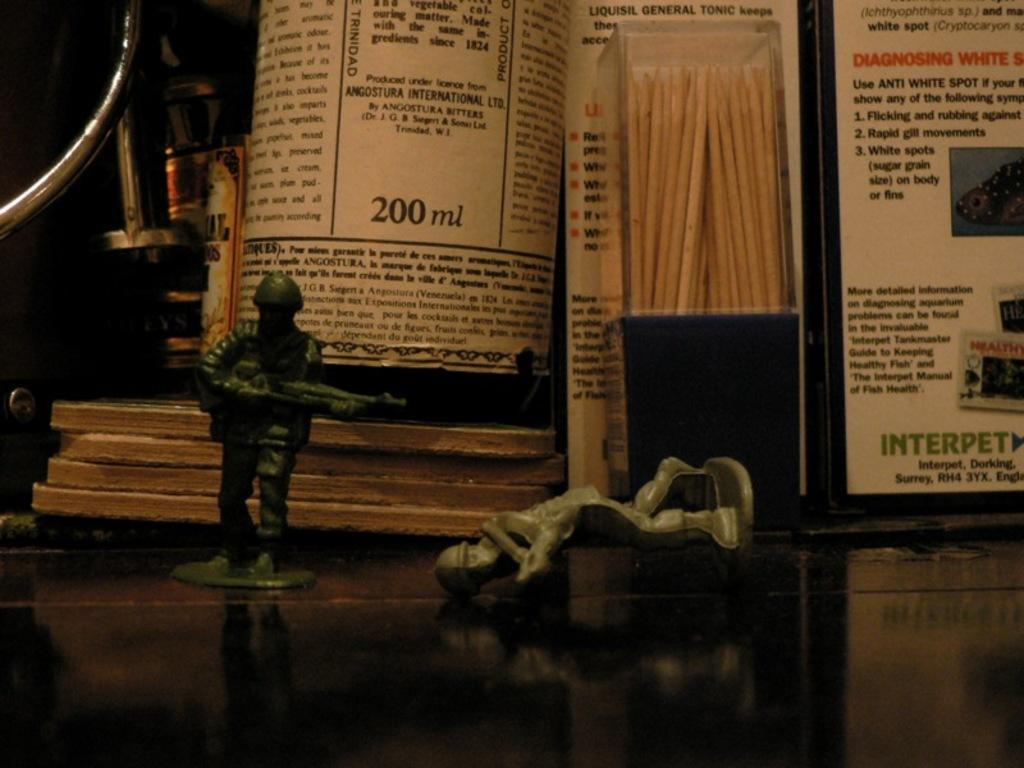What objects are present in the image? There are figurines in the image, which are placed on a surface. What other objects can be seen in the background of the image? In the background, there is a bottle, a box, boards, and an unspecified object. Can you describe the surface on which the figurines are placed? The provided facts do not specify the surface on which the figurines are placed. What type of finger can be seen holding the figurine in the image? There is no finger holding the figurine in the image; the provided facts do not mention any hands or fingers. 